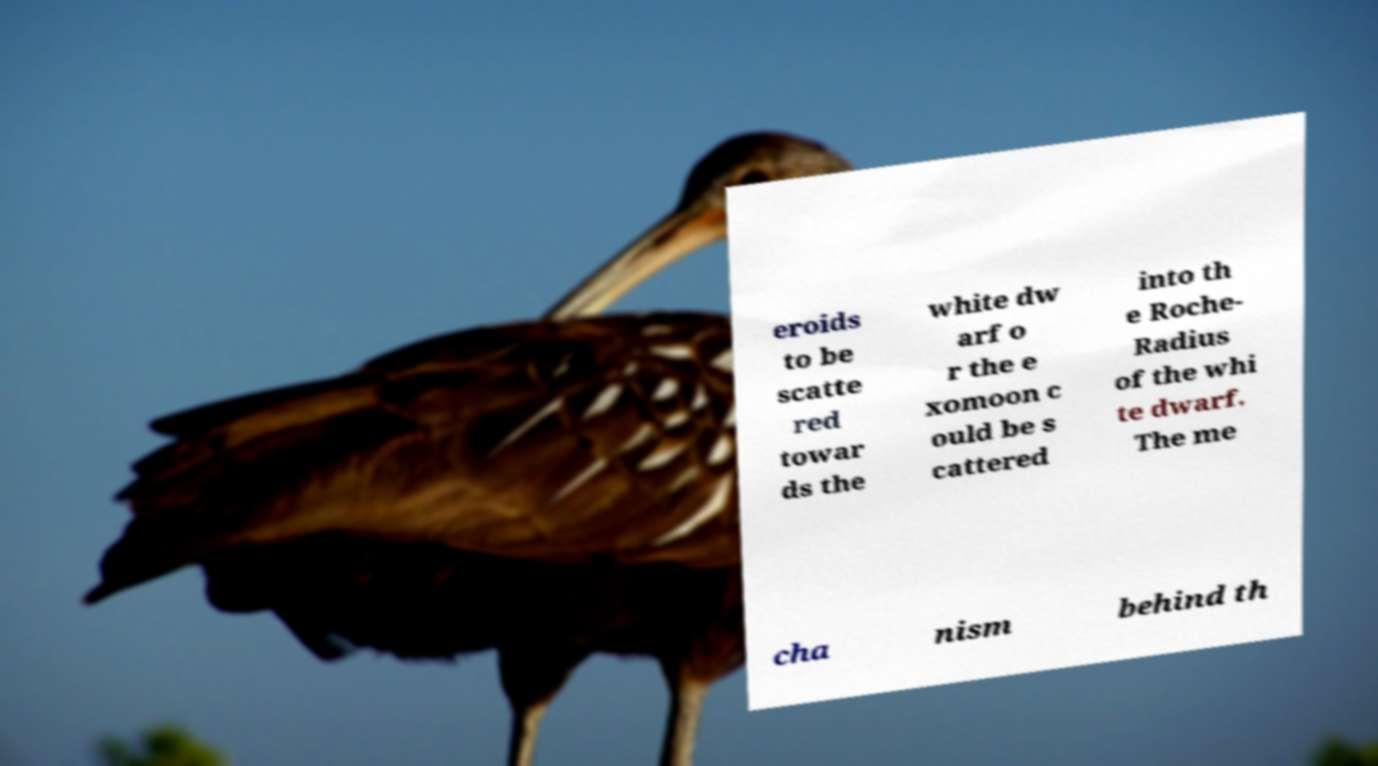I need the written content from this picture converted into text. Can you do that? eroids to be scatte red towar ds the white dw arf o r the e xomoon c ould be s cattered into th e Roche- Radius of the whi te dwarf. The me cha nism behind th 